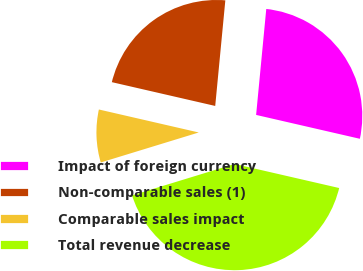Convert chart to OTSL. <chart><loc_0><loc_0><loc_500><loc_500><pie_chart><fcel>Impact of foreign currency<fcel>Non-comparable sales (1)<fcel>Comparable sales impact<fcel>Total revenue decrease<nl><fcel>27.08%<fcel>22.92%<fcel>8.33%<fcel>41.67%<nl></chart> 